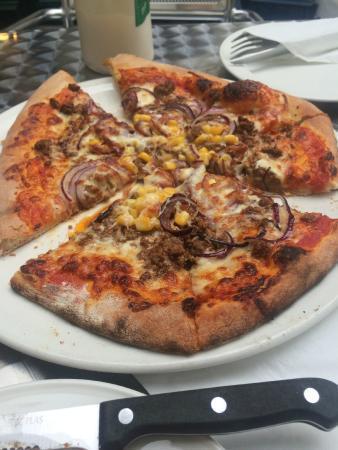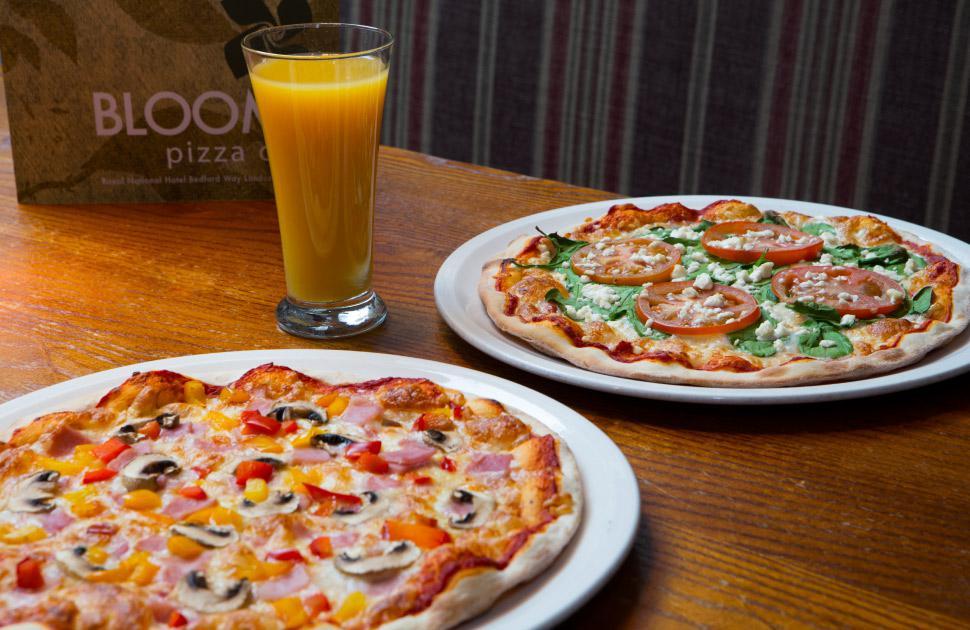The first image is the image on the left, the second image is the image on the right. For the images shown, is this caption "There are two pizzas in the right image." true? Answer yes or no. Yes. 